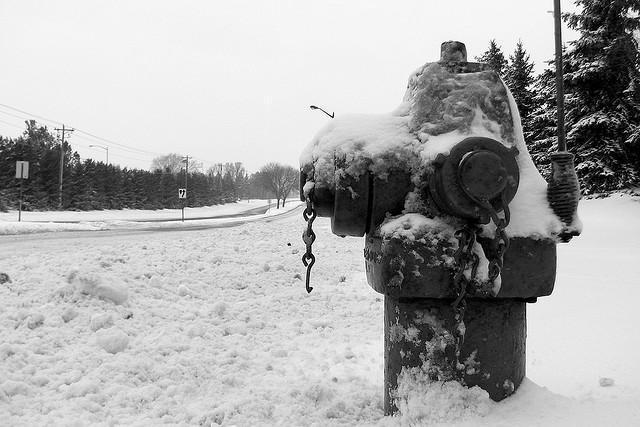How many street signs are there?
Give a very brief answer. 2. 